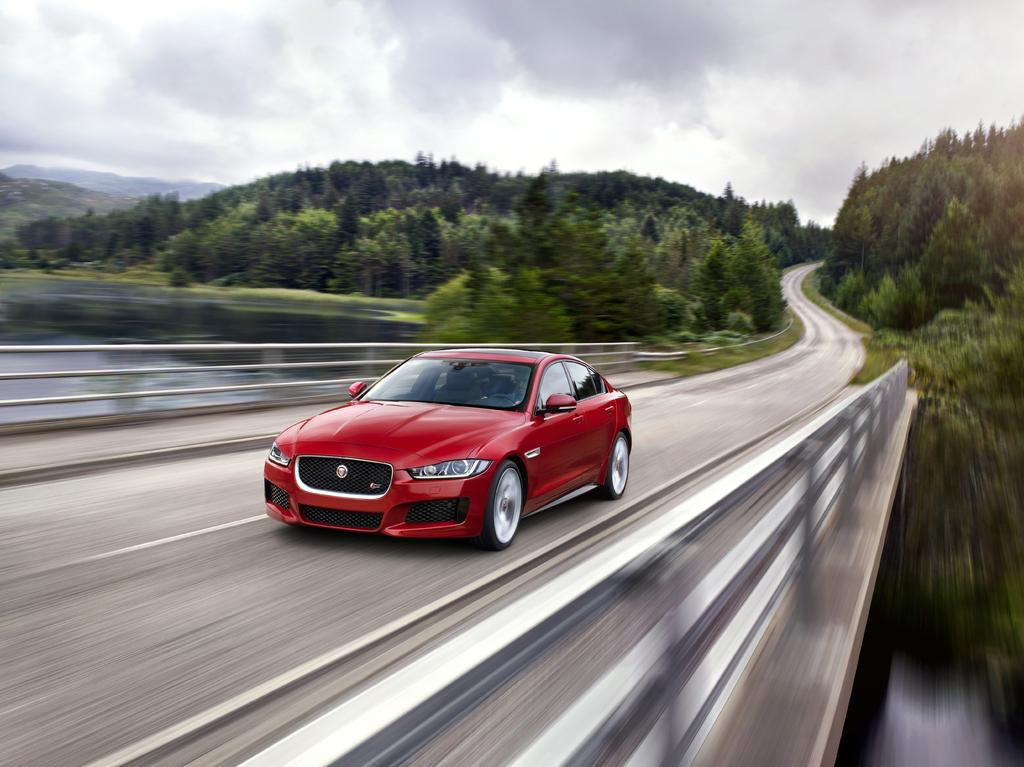What is the main subject of the image? There is a car in the image. How is the car behaving in the image? The car is moving fast in the image. Where is the car located in the image? The car is on a bridge in the image. What can be seen below the bridge? There is water below the bridge. What type of vegetation is visible in the background of the image? There are trees in the background on either side of the road. What is visible at the top of the image? The sky is visible at the top of the image. Can you see an ant carrying a light on the bridge in the image? There is no ant or light present on the bridge in the image. Is there a boat visible in the water below the bridge in the image? There is no boat visible in the water below the bridge in the image. 